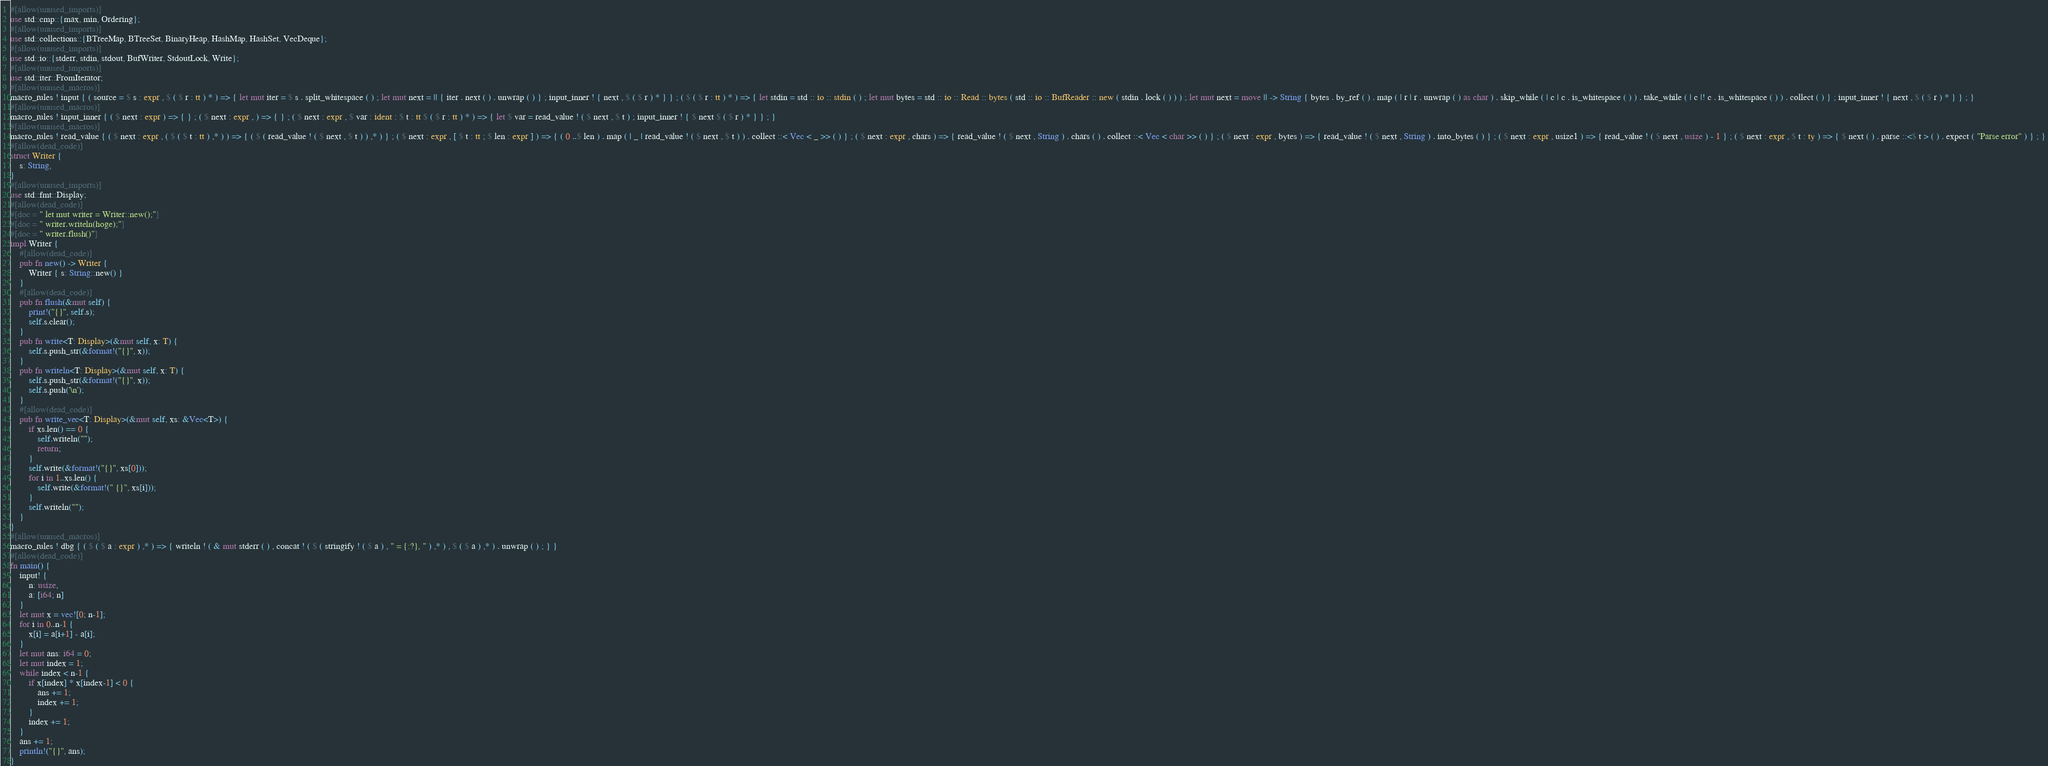<code> <loc_0><loc_0><loc_500><loc_500><_Rust_>#[allow(unused_imports)]
use std::cmp::{max, min, Ordering};
#[allow(unused_imports)]
use std::collections::{BTreeMap, BTreeSet, BinaryHeap, HashMap, HashSet, VecDeque};
#[allow(unused_imports)]
use std::io::{stderr, stdin, stdout, BufWriter, StdoutLock, Write};
#[allow(unused_imports)]
use std::iter::FromIterator;
#[allow(unused_macros)]
macro_rules ! input { ( source = $ s : expr , $ ( $ r : tt ) * ) => { let mut iter = $ s . split_whitespace ( ) ; let mut next = || { iter . next ( ) . unwrap ( ) } ; input_inner ! { next , $ ( $ r ) * } } ; ( $ ( $ r : tt ) * ) => { let stdin = std :: io :: stdin ( ) ; let mut bytes = std :: io :: Read :: bytes ( std :: io :: BufReader :: new ( stdin . lock ( ) ) ) ; let mut next = move || -> String { bytes . by_ref ( ) . map ( | r | r . unwrap ( ) as char ) . skip_while ( | c | c . is_whitespace ( ) ) . take_while ( | c |! c . is_whitespace ( ) ) . collect ( ) } ; input_inner ! { next , $ ( $ r ) * } } ; }
#[allow(unused_macros)]
macro_rules ! input_inner { ( $ next : expr ) => { } ; ( $ next : expr , ) => { } ; ( $ next : expr , $ var : ident : $ t : tt $ ( $ r : tt ) * ) => { let $ var = read_value ! ( $ next , $ t ) ; input_inner ! { $ next $ ( $ r ) * } } ; }
#[allow(unused_macros)]
macro_rules ! read_value { ( $ next : expr , ( $ ( $ t : tt ) ,* ) ) => { ( $ ( read_value ! ( $ next , $ t ) ) ,* ) } ; ( $ next : expr , [ $ t : tt ; $ len : expr ] ) => { ( 0 ..$ len ) . map ( | _ | read_value ! ( $ next , $ t ) ) . collect ::< Vec < _ >> ( ) } ; ( $ next : expr , chars ) => { read_value ! ( $ next , String ) . chars ( ) . collect ::< Vec < char >> ( ) } ; ( $ next : expr , bytes ) => { read_value ! ( $ next , String ) . into_bytes ( ) } ; ( $ next : expr , usize1 ) => { read_value ! ( $ next , usize ) - 1 } ; ( $ next : expr , $ t : ty ) => { $ next ( ) . parse ::<$ t > ( ) . expect ( "Parse error" ) } ; }
#[allow(dead_code)]
struct Writer {
    s: String,
}
#[allow(unused_imports)]
use std::fmt::Display;
#[allow(dead_code)]
#[doc = " let mut writer = Writer::new();"]
#[doc = " writer.writeln(hoge);"]
#[doc = " writer.flush()"]
impl Writer {
    #[allow(dead_code)]
    pub fn new() -> Writer {
        Writer { s: String::new() }
    }
    #[allow(dead_code)]
    pub fn flush(&mut self) {
        print!("{}", self.s);
        self.s.clear();
    }
    pub fn write<T: Display>(&mut self, x: T) {
        self.s.push_str(&format!("{}", x));
    }
    pub fn writeln<T: Display>(&mut self, x: T) {
        self.s.push_str(&format!("{}", x));
        self.s.push('\n');
    }
    #[allow(dead_code)]
    pub fn write_vec<T: Display>(&mut self, xs: &Vec<T>) {
        if xs.len() == 0 {
            self.writeln("");
            return;
        }
        self.write(&format!("{}", xs[0]));
        for i in 1..xs.len() {
            self.write(&format!(" {}", xs[i]));
        }
        self.writeln("");
    }
}
#[allow(unused_macros)]
macro_rules ! dbg { ( $ ( $ a : expr ) ,* ) => { writeln ! ( & mut stderr ( ) , concat ! ( $ ( stringify ! ( $ a ) , " = {:?}, " ) ,* ) , $ ( $ a ) ,* ) . unwrap ( ) ; } }
#[allow(dead_code)]
fn main() {
    input! {
        n: usize,
        a: [i64; n]
    }
    let mut x = vec![0; n-1];
    for i in 0..n-1 {
        x[i] = a[i+1] - a[i];
    }
    let mut ans: i64 = 0;
    let mut index = 1;
    while index < n-1 {
        if x[index] * x[index-1] < 0 {
            ans += 1;
            index += 1;
        }
        index += 1;
    }
    ans += 1;
    println!("{}", ans);
}</code> 